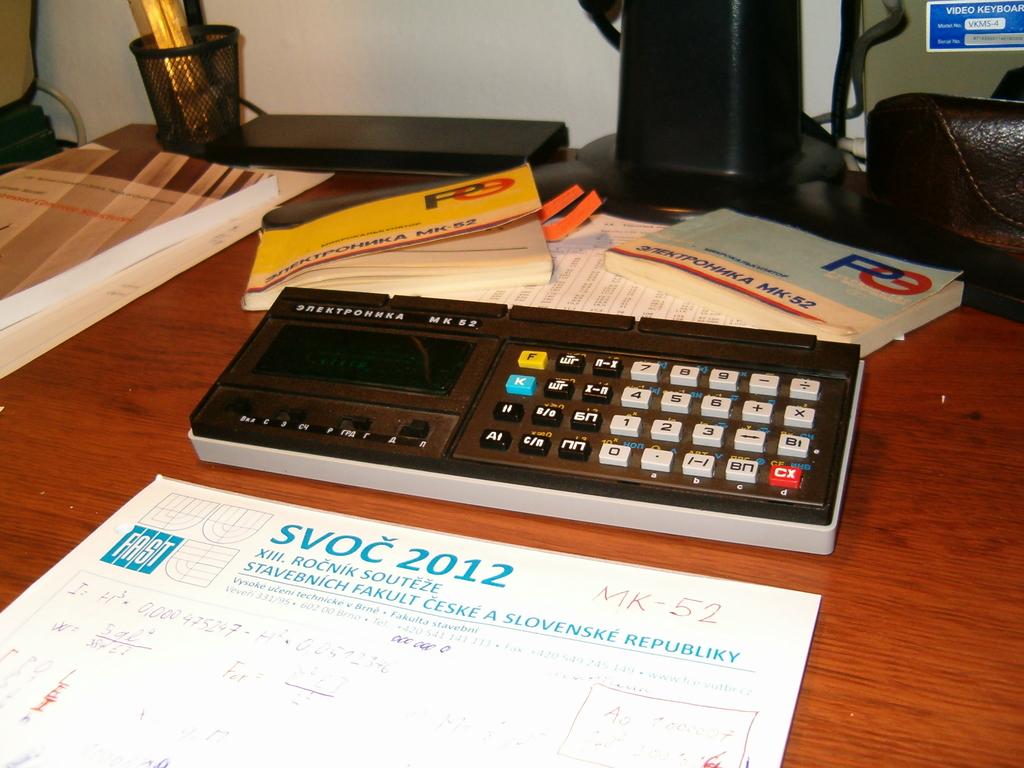What number is listed on the paper?
Offer a very short reply. 2012. What is the name of the document on the table?
Provide a short and direct response. Svoc 2012. 